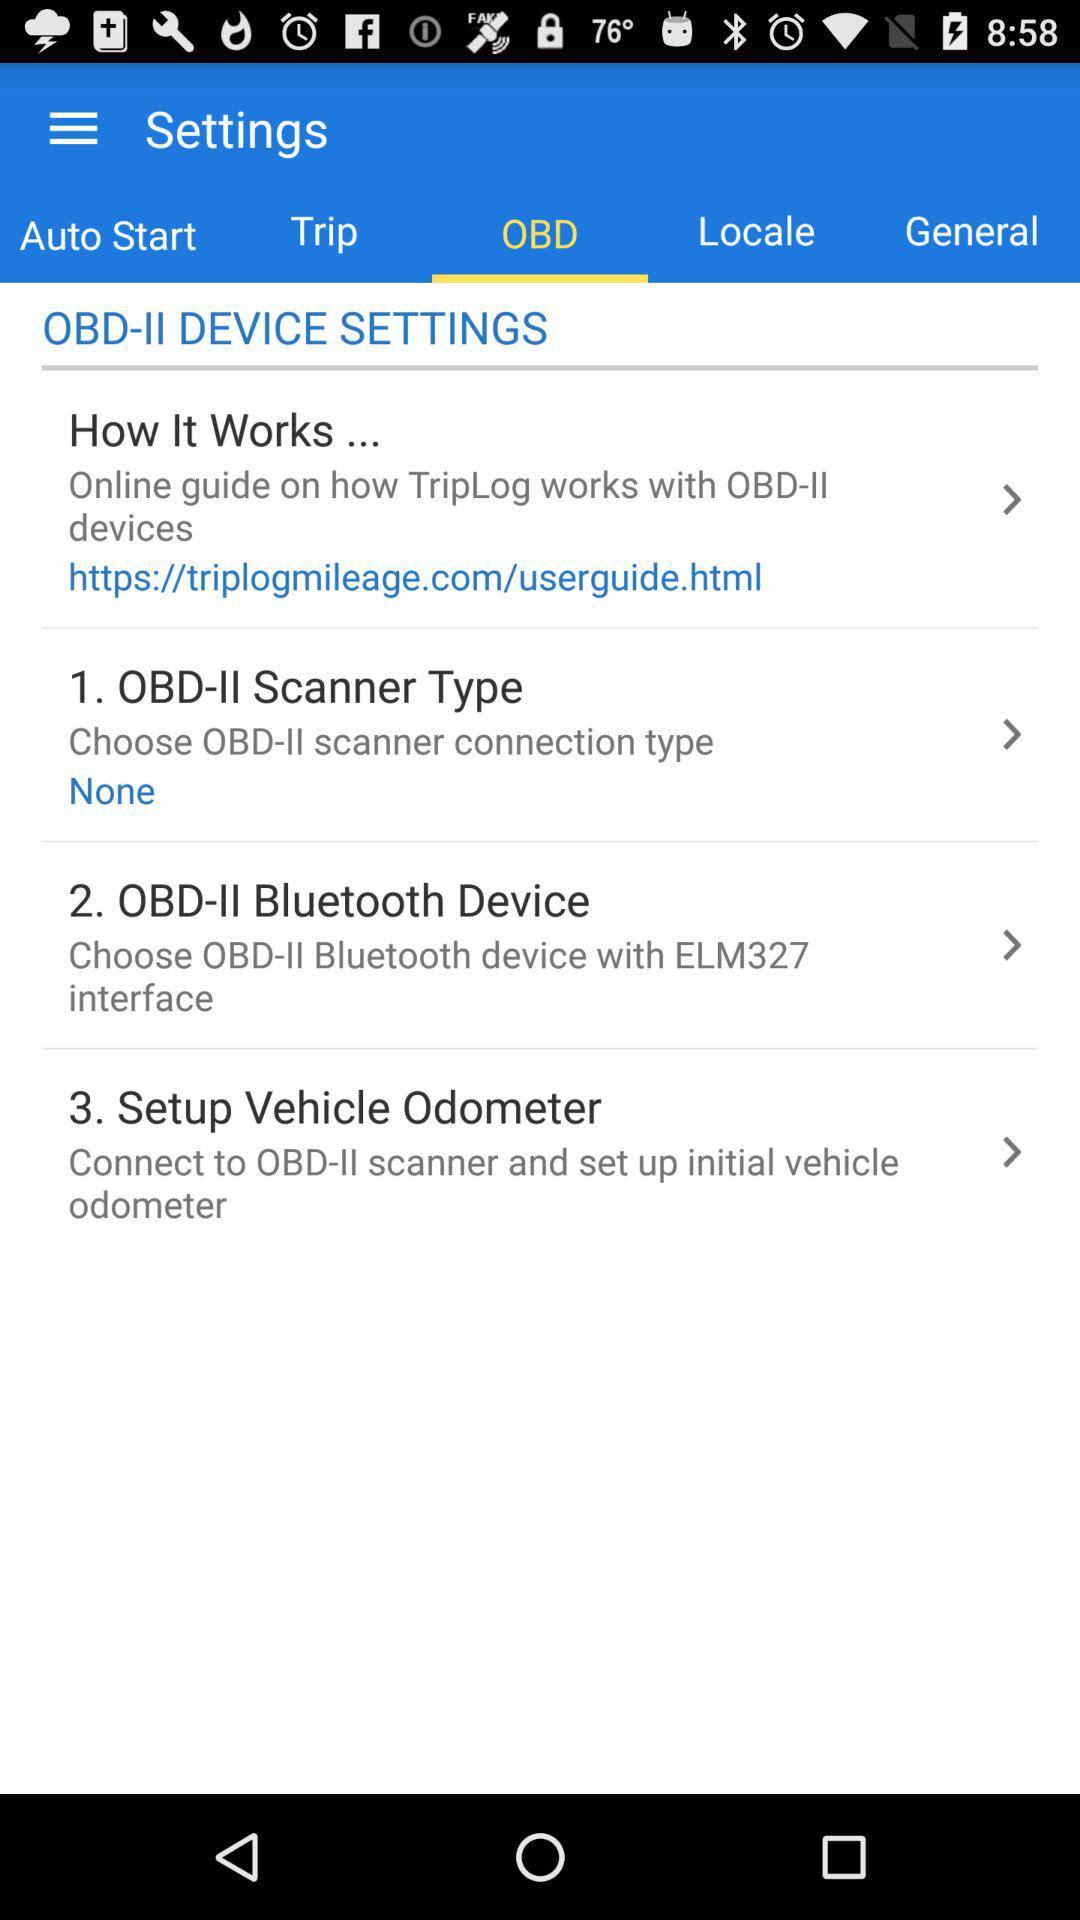How many steps are there in the OBD-II device settings?
Answer the question using a single word or phrase. 3 